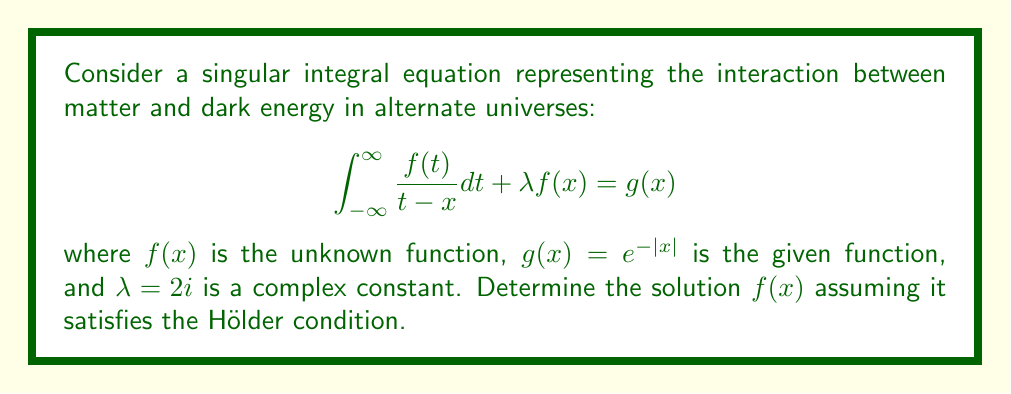Show me your answer to this math problem. To solve this singular integral equation, we'll follow these steps:

1) Recognize this as a Cauchy-type singular integral equation.

2) Apply the Sokhotski-Plemelj formula:
   $$f(x) = \frac{1}{2\pi i} \int_{-\infty}^{\infty} \frac{f(t)}{t-x} dt$$

3) Substitute this into the original equation:
   $$\pi i f(x) + \lambda f(x) = g(x)$$

4) Simplify:
   $$(\pi i + \lambda)f(x) = g(x)$$
   $$(\pi i + 2i)f(x) = e^{-|x|}$$

5) Solve for $f(x)$:
   $$f(x) = \frac{e^{-|x|}}{\pi i + 2i} = \frac{e^{-|x|}}{i(\pi + 2)}$$

6) Simplify the denominator:
   $$f(x) = -\frac{i e^{-|x|}}{\pi + 2}$$

This solution represents the distribution of matter-dark energy interaction across alternate universes, with the exponential decay indicating a diminishing effect in more distant universes.
Answer: $f(x) = -\frac{i e^{-|x|}}{\pi + 2}$ 